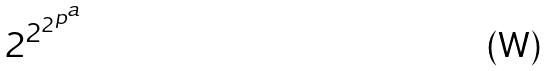Convert formula to latex. <formula><loc_0><loc_0><loc_500><loc_500>2 ^ { 2 ^ { 2 ^ { p ^ { a } } } }</formula> 